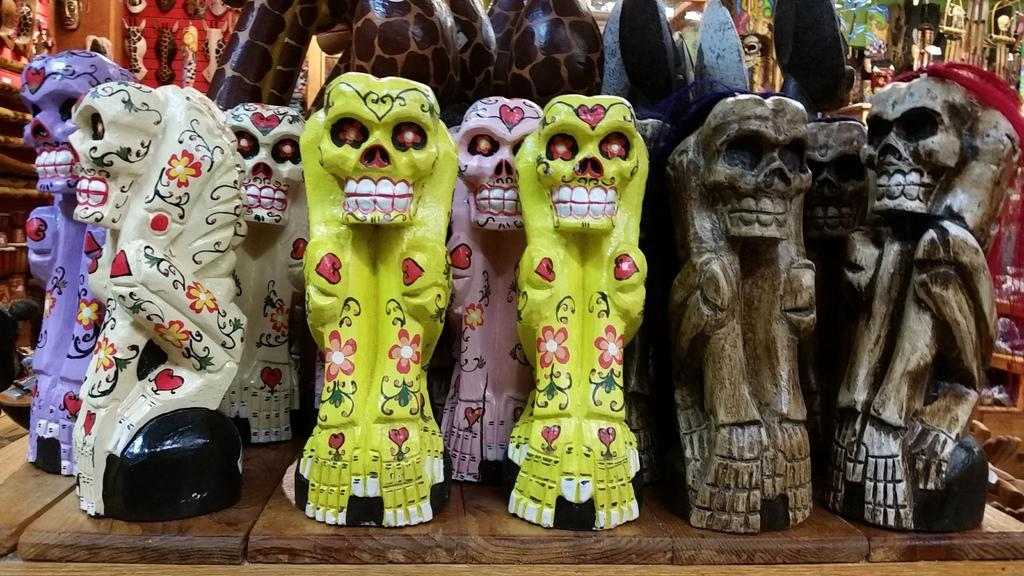What type of objects can be seen in the image? There are sculptures in the image. What is the material of the surface on which the sculptures are placed? The sculptures are on a wooden surface. What type of doll is sitting on the slope in the image? There is no doll or slope present in the image; it features sculptures on a wooden surface. 